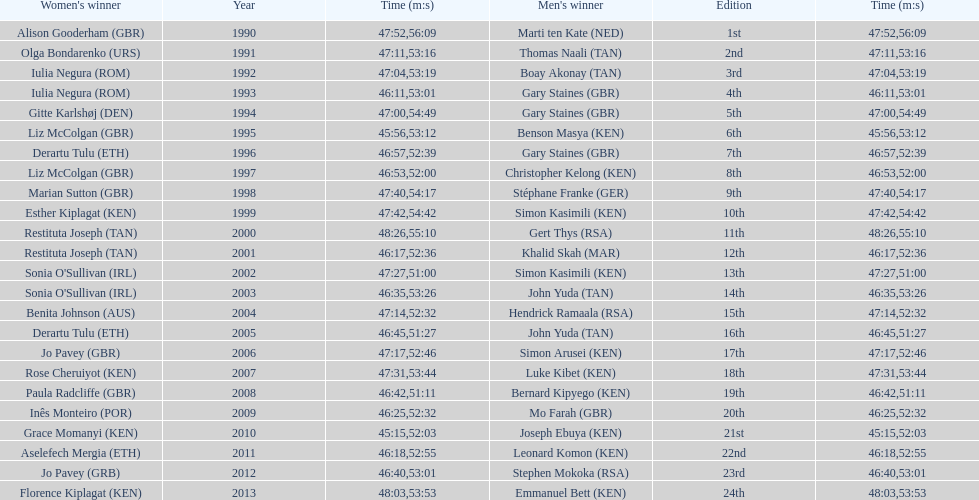Number of men's winners with a finish time under 46:58 12. 